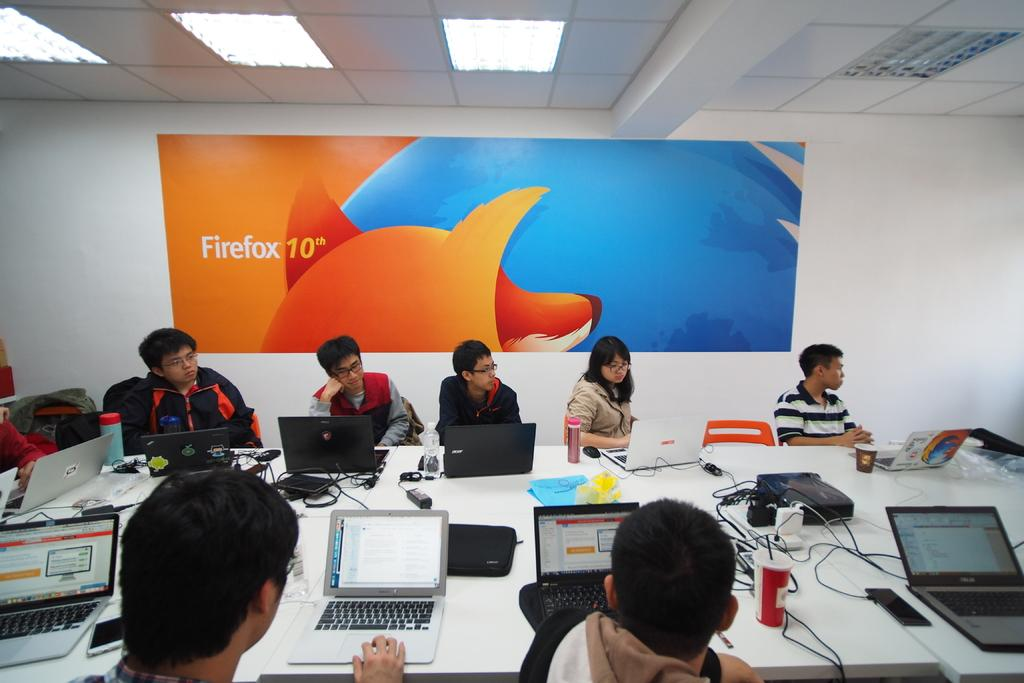<image>
Provide a brief description of the given image. A painting that says firefox 10th it's orange and blue. 